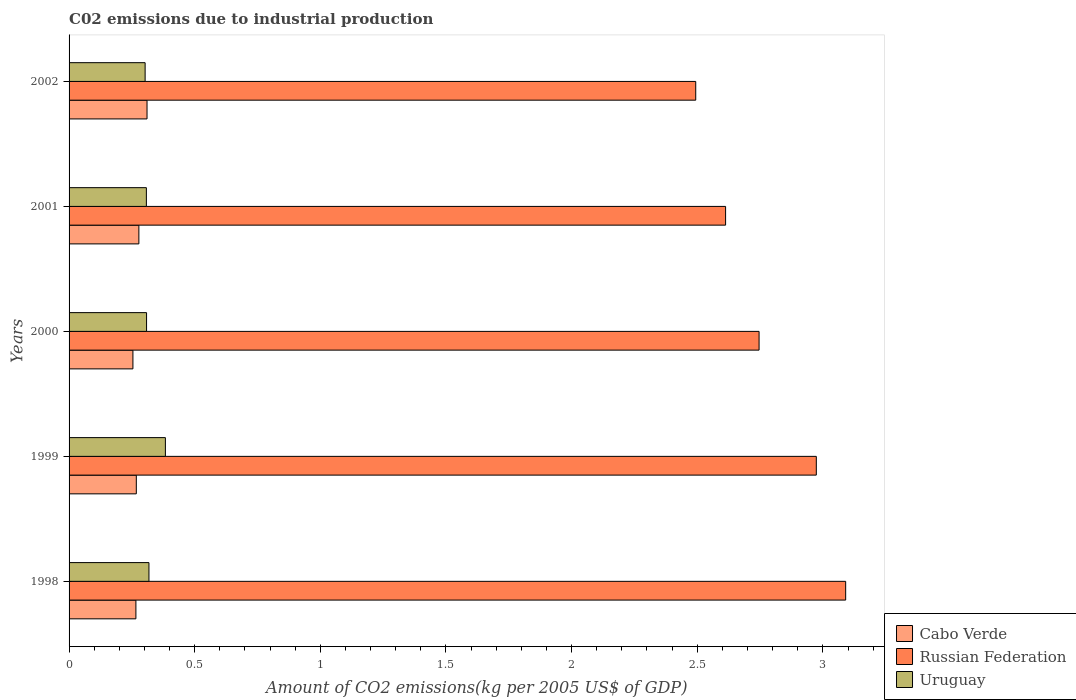How many groups of bars are there?
Your response must be concise. 5. Are the number of bars on each tick of the Y-axis equal?
Make the answer very short. Yes. How many bars are there on the 1st tick from the bottom?
Provide a succinct answer. 3. What is the label of the 2nd group of bars from the top?
Your answer should be very brief. 2001. What is the amount of CO2 emitted due to industrial production in Cabo Verde in 2001?
Ensure brevity in your answer.  0.28. Across all years, what is the maximum amount of CO2 emitted due to industrial production in Cabo Verde?
Offer a very short reply. 0.31. Across all years, what is the minimum amount of CO2 emitted due to industrial production in Uruguay?
Your answer should be very brief. 0.3. In which year was the amount of CO2 emitted due to industrial production in Russian Federation minimum?
Provide a short and direct response. 2002. What is the total amount of CO2 emitted due to industrial production in Uruguay in the graph?
Give a very brief answer. 1.62. What is the difference between the amount of CO2 emitted due to industrial production in Uruguay in 1999 and that in 2002?
Give a very brief answer. 0.08. What is the difference between the amount of CO2 emitted due to industrial production in Uruguay in 2001 and the amount of CO2 emitted due to industrial production in Cabo Verde in 1999?
Your answer should be very brief. 0.04. What is the average amount of CO2 emitted due to industrial production in Russian Federation per year?
Give a very brief answer. 2.78. In the year 1998, what is the difference between the amount of CO2 emitted due to industrial production in Uruguay and amount of CO2 emitted due to industrial production in Cabo Verde?
Keep it short and to the point. 0.05. In how many years, is the amount of CO2 emitted due to industrial production in Cabo Verde greater than 0.8 kg?
Keep it short and to the point. 0. What is the ratio of the amount of CO2 emitted due to industrial production in Cabo Verde in 1998 to that in 2001?
Your response must be concise. 0.96. What is the difference between the highest and the second highest amount of CO2 emitted due to industrial production in Russian Federation?
Make the answer very short. 0.12. What is the difference between the highest and the lowest amount of CO2 emitted due to industrial production in Uruguay?
Ensure brevity in your answer.  0.08. Is the sum of the amount of CO2 emitted due to industrial production in Cabo Verde in 1999 and 2000 greater than the maximum amount of CO2 emitted due to industrial production in Uruguay across all years?
Your response must be concise. Yes. What does the 2nd bar from the top in 2000 represents?
Ensure brevity in your answer.  Russian Federation. What does the 3rd bar from the bottom in 1998 represents?
Give a very brief answer. Uruguay. How many bars are there?
Offer a terse response. 15. Are all the bars in the graph horizontal?
Give a very brief answer. Yes. How many years are there in the graph?
Provide a short and direct response. 5. Are the values on the major ticks of X-axis written in scientific E-notation?
Keep it short and to the point. No. Does the graph contain any zero values?
Offer a very short reply. No. Does the graph contain grids?
Your answer should be very brief. No. Where does the legend appear in the graph?
Your response must be concise. Bottom right. How are the legend labels stacked?
Make the answer very short. Vertical. What is the title of the graph?
Give a very brief answer. C02 emissions due to industrial production. What is the label or title of the X-axis?
Make the answer very short. Amount of CO2 emissions(kg per 2005 US$ of GDP). What is the label or title of the Y-axis?
Offer a terse response. Years. What is the Amount of CO2 emissions(kg per 2005 US$ of GDP) in Cabo Verde in 1998?
Offer a very short reply. 0.27. What is the Amount of CO2 emissions(kg per 2005 US$ of GDP) in Russian Federation in 1998?
Make the answer very short. 3.09. What is the Amount of CO2 emissions(kg per 2005 US$ of GDP) in Uruguay in 1998?
Ensure brevity in your answer.  0.32. What is the Amount of CO2 emissions(kg per 2005 US$ of GDP) of Cabo Verde in 1999?
Your answer should be compact. 0.27. What is the Amount of CO2 emissions(kg per 2005 US$ of GDP) in Russian Federation in 1999?
Your answer should be compact. 2.97. What is the Amount of CO2 emissions(kg per 2005 US$ of GDP) of Uruguay in 1999?
Provide a succinct answer. 0.38. What is the Amount of CO2 emissions(kg per 2005 US$ of GDP) in Cabo Verde in 2000?
Your answer should be compact. 0.25. What is the Amount of CO2 emissions(kg per 2005 US$ of GDP) in Russian Federation in 2000?
Your answer should be compact. 2.75. What is the Amount of CO2 emissions(kg per 2005 US$ of GDP) of Uruguay in 2000?
Your answer should be very brief. 0.31. What is the Amount of CO2 emissions(kg per 2005 US$ of GDP) in Cabo Verde in 2001?
Provide a short and direct response. 0.28. What is the Amount of CO2 emissions(kg per 2005 US$ of GDP) in Russian Federation in 2001?
Offer a terse response. 2.61. What is the Amount of CO2 emissions(kg per 2005 US$ of GDP) in Uruguay in 2001?
Provide a succinct answer. 0.31. What is the Amount of CO2 emissions(kg per 2005 US$ of GDP) of Cabo Verde in 2002?
Provide a short and direct response. 0.31. What is the Amount of CO2 emissions(kg per 2005 US$ of GDP) of Russian Federation in 2002?
Give a very brief answer. 2.49. What is the Amount of CO2 emissions(kg per 2005 US$ of GDP) of Uruguay in 2002?
Ensure brevity in your answer.  0.3. Across all years, what is the maximum Amount of CO2 emissions(kg per 2005 US$ of GDP) of Cabo Verde?
Ensure brevity in your answer.  0.31. Across all years, what is the maximum Amount of CO2 emissions(kg per 2005 US$ of GDP) of Russian Federation?
Your answer should be compact. 3.09. Across all years, what is the maximum Amount of CO2 emissions(kg per 2005 US$ of GDP) in Uruguay?
Ensure brevity in your answer.  0.38. Across all years, what is the minimum Amount of CO2 emissions(kg per 2005 US$ of GDP) of Cabo Verde?
Offer a terse response. 0.25. Across all years, what is the minimum Amount of CO2 emissions(kg per 2005 US$ of GDP) of Russian Federation?
Your response must be concise. 2.49. Across all years, what is the minimum Amount of CO2 emissions(kg per 2005 US$ of GDP) in Uruguay?
Make the answer very short. 0.3. What is the total Amount of CO2 emissions(kg per 2005 US$ of GDP) of Cabo Verde in the graph?
Ensure brevity in your answer.  1.38. What is the total Amount of CO2 emissions(kg per 2005 US$ of GDP) in Russian Federation in the graph?
Ensure brevity in your answer.  13.92. What is the total Amount of CO2 emissions(kg per 2005 US$ of GDP) of Uruguay in the graph?
Ensure brevity in your answer.  1.62. What is the difference between the Amount of CO2 emissions(kg per 2005 US$ of GDP) of Cabo Verde in 1998 and that in 1999?
Your response must be concise. -0. What is the difference between the Amount of CO2 emissions(kg per 2005 US$ of GDP) in Russian Federation in 1998 and that in 1999?
Make the answer very short. 0.12. What is the difference between the Amount of CO2 emissions(kg per 2005 US$ of GDP) of Uruguay in 1998 and that in 1999?
Provide a succinct answer. -0.07. What is the difference between the Amount of CO2 emissions(kg per 2005 US$ of GDP) of Cabo Verde in 1998 and that in 2000?
Your response must be concise. 0.01. What is the difference between the Amount of CO2 emissions(kg per 2005 US$ of GDP) of Russian Federation in 1998 and that in 2000?
Your answer should be very brief. 0.34. What is the difference between the Amount of CO2 emissions(kg per 2005 US$ of GDP) of Uruguay in 1998 and that in 2000?
Keep it short and to the point. 0.01. What is the difference between the Amount of CO2 emissions(kg per 2005 US$ of GDP) in Cabo Verde in 1998 and that in 2001?
Ensure brevity in your answer.  -0.01. What is the difference between the Amount of CO2 emissions(kg per 2005 US$ of GDP) in Russian Federation in 1998 and that in 2001?
Offer a very short reply. 0.48. What is the difference between the Amount of CO2 emissions(kg per 2005 US$ of GDP) of Uruguay in 1998 and that in 2001?
Keep it short and to the point. 0.01. What is the difference between the Amount of CO2 emissions(kg per 2005 US$ of GDP) in Cabo Verde in 1998 and that in 2002?
Give a very brief answer. -0.04. What is the difference between the Amount of CO2 emissions(kg per 2005 US$ of GDP) in Russian Federation in 1998 and that in 2002?
Offer a terse response. 0.6. What is the difference between the Amount of CO2 emissions(kg per 2005 US$ of GDP) of Uruguay in 1998 and that in 2002?
Provide a short and direct response. 0.02. What is the difference between the Amount of CO2 emissions(kg per 2005 US$ of GDP) in Cabo Verde in 1999 and that in 2000?
Ensure brevity in your answer.  0.01. What is the difference between the Amount of CO2 emissions(kg per 2005 US$ of GDP) in Russian Federation in 1999 and that in 2000?
Keep it short and to the point. 0.23. What is the difference between the Amount of CO2 emissions(kg per 2005 US$ of GDP) in Uruguay in 1999 and that in 2000?
Offer a very short reply. 0.07. What is the difference between the Amount of CO2 emissions(kg per 2005 US$ of GDP) of Cabo Verde in 1999 and that in 2001?
Make the answer very short. -0.01. What is the difference between the Amount of CO2 emissions(kg per 2005 US$ of GDP) of Russian Federation in 1999 and that in 2001?
Your answer should be compact. 0.36. What is the difference between the Amount of CO2 emissions(kg per 2005 US$ of GDP) of Uruguay in 1999 and that in 2001?
Make the answer very short. 0.08. What is the difference between the Amount of CO2 emissions(kg per 2005 US$ of GDP) of Cabo Verde in 1999 and that in 2002?
Keep it short and to the point. -0.04. What is the difference between the Amount of CO2 emissions(kg per 2005 US$ of GDP) in Russian Federation in 1999 and that in 2002?
Keep it short and to the point. 0.48. What is the difference between the Amount of CO2 emissions(kg per 2005 US$ of GDP) in Uruguay in 1999 and that in 2002?
Your answer should be compact. 0.08. What is the difference between the Amount of CO2 emissions(kg per 2005 US$ of GDP) of Cabo Verde in 2000 and that in 2001?
Give a very brief answer. -0.02. What is the difference between the Amount of CO2 emissions(kg per 2005 US$ of GDP) of Russian Federation in 2000 and that in 2001?
Offer a terse response. 0.13. What is the difference between the Amount of CO2 emissions(kg per 2005 US$ of GDP) of Uruguay in 2000 and that in 2001?
Offer a very short reply. 0. What is the difference between the Amount of CO2 emissions(kg per 2005 US$ of GDP) of Cabo Verde in 2000 and that in 2002?
Provide a short and direct response. -0.06. What is the difference between the Amount of CO2 emissions(kg per 2005 US$ of GDP) of Russian Federation in 2000 and that in 2002?
Give a very brief answer. 0.25. What is the difference between the Amount of CO2 emissions(kg per 2005 US$ of GDP) in Uruguay in 2000 and that in 2002?
Keep it short and to the point. 0.01. What is the difference between the Amount of CO2 emissions(kg per 2005 US$ of GDP) of Cabo Verde in 2001 and that in 2002?
Give a very brief answer. -0.03. What is the difference between the Amount of CO2 emissions(kg per 2005 US$ of GDP) of Russian Federation in 2001 and that in 2002?
Provide a short and direct response. 0.12. What is the difference between the Amount of CO2 emissions(kg per 2005 US$ of GDP) in Uruguay in 2001 and that in 2002?
Provide a short and direct response. 0.01. What is the difference between the Amount of CO2 emissions(kg per 2005 US$ of GDP) in Cabo Verde in 1998 and the Amount of CO2 emissions(kg per 2005 US$ of GDP) in Russian Federation in 1999?
Make the answer very short. -2.71. What is the difference between the Amount of CO2 emissions(kg per 2005 US$ of GDP) of Cabo Verde in 1998 and the Amount of CO2 emissions(kg per 2005 US$ of GDP) of Uruguay in 1999?
Offer a very short reply. -0.12. What is the difference between the Amount of CO2 emissions(kg per 2005 US$ of GDP) of Russian Federation in 1998 and the Amount of CO2 emissions(kg per 2005 US$ of GDP) of Uruguay in 1999?
Your answer should be very brief. 2.71. What is the difference between the Amount of CO2 emissions(kg per 2005 US$ of GDP) of Cabo Verde in 1998 and the Amount of CO2 emissions(kg per 2005 US$ of GDP) of Russian Federation in 2000?
Your answer should be very brief. -2.48. What is the difference between the Amount of CO2 emissions(kg per 2005 US$ of GDP) of Cabo Verde in 1998 and the Amount of CO2 emissions(kg per 2005 US$ of GDP) of Uruguay in 2000?
Your answer should be compact. -0.04. What is the difference between the Amount of CO2 emissions(kg per 2005 US$ of GDP) of Russian Federation in 1998 and the Amount of CO2 emissions(kg per 2005 US$ of GDP) of Uruguay in 2000?
Ensure brevity in your answer.  2.78. What is the difference between the Amount of CO2 emissions(kg per 2005 US$ of GDP) of Cabo Verde in 1998 and the Amount of CO2 emissions(kg per 2005 US$ of GDP) of Russian Federation in 2001?
Offer a very short reply. -2.35. What is the difference between the Amount of CO2 emissions(kg per 2005 US$ of GDP) in Cabo Verde in 1998 and the Amount of CO2 emissions(kg per 2005 US$ of GDP) in Uruguay in 2001?
Offer a terse response. -0.04. What is the difference between the Amount of CO2 emissions(kg per 2005 US$ of GDP) of Russian Federation in 1998 and the Amount of CO2 emissions(kg per 2005 US$ of GDP) of Uruguay in 2001?
Your response must be concise. 2.78. What is the difference between the Amount of CO2 emissions(kg per 2005 US$ of GDP) of Cabo Verde in 1998 and the Amount of CO2 emissions(kg per 2005 US$ of GDP) of Russian Federation in 2002?
Your answer should be compact. -2.23. What is the difference between the Amount of CO2 emissions(kg per 2005 US$ of GDP) of Cabo Verde in 1998 and the Amount of CO2 emissions(kg per 2005 US$ of GDP) of Uruguay in 2002?
Offer a very short reply. -0.04. What is the difference between the Amount of CO2 emissions(kg per 2005 US$ of GDP) of Russian Federation in 1998 and the Amount of CO2 emissions(kg per 2005 US$ of GDP) of Uruguay in 2002?
Keep it short and to the point. 2.79. What is the difference between the Amount of CO2 emissions(kg per 2005 US$ of GDP) of Cabo Verde in 1999 and the Amount of CO2 emissions(kg per 2005 US$ of GDP) of Russian Federation in 2000?
Offer a terse response. -2.48. What is the difference between the Amount of CO2 emissions(kg per 2005 US$ of GDP) of Cabo Verde in 1999 and the Amount of CO2 emissions(kg per 2005 US$ of GDP) of Uruguay in 2000?
Your answer should be compact. -0.04. What is the difference between the Amount of CO2 emissions(kg per 2005 US$ of GDP) of Russian Federation in 1999 and the Amount of CO2 emissions(kg per 2005 US$ of GDP) of Uruguay in 2000?
Keep it short and to the point. 2.67. What is the difference between the Amount of CO2 emissions(kg per 2005 US$ of GDP) in Cabo Verde in 1999 and the Amount of CO2 emissions(kg per 2005 US$ of GDP) in Russian Federation in 2001?
Provide a short and direct response. -2.35. What is the difference between the Amount of CO2 emissions(kg per 2005 US$ of GDP) in Cabo Verde in 1999 and the Amount of CO2 emissions(kg per 2005 US$ of GDP) in Uruguay in 2001?
Your answer should be compact. -0.04. What is the difference between the Amount of CO2 emissions(kg per 2005 US$ of GDP) of Russian Federation in 1999 and the Amount of CO2 emissions(kg per 2005 US$ of GDP) of Uruguay in 2001?
Provide a succinct answer. 2.67. What is the difference between the Amount of CO2 emissions(kg per 2005 US$ of GDP) in Cabo Verde in 1999 and the Amount of CO2 emissions(kg per 2005 US$ of GDP) in Russian Federation in 2002?
Ensure brevity in your answer.  -2.23. What is the difference between the Amount of CO2 emissions(kg per 2005 US$ of GDP) of Cabo Verde in 1999 and the Amount of CO2 emissions(kg per 2005 US$ of GDP) of Uruguay in 2002?
Your answer should be very brief. -0.04. What is the difference between the Amount of CO2 emissions(kg per 2005 US$ of GDP) in Russian Federation in 1999 and the Amount of CO2 emissions(kg per 2005 US$ of GDP) in Uruguay in 2002?
Ensure brevity in your answer.  2.67. What is the difference between the Amount of CO2 emissions(kg per 2005 US$ of GDP) in Cabo Verde in 2000 and the Amount of CO2 emissions(kg per 2005 US$ of GDP) in Russian Federation in 2001?
Make the answer very short. -2.36. What is the difference between the Amount of CO2 emissions(kg per 2005 US$ of GDP) in Cabo Verde in 2000 and the Amount of CO2 emissions(kg per 2005 US$ of GDP) in Uruguay in 2001?
Your response must be concise. -0.05. What is the difference between the Amount of CO2 emissions(kg per 2005 US$ of GDP) of Russian Federation in 2000 and the Amount of CO2 emissions(kg per 2005 US$ of GDP) of Uruguay in 2001?
Your answer should be very brief. 2.44. What is the difference between the Amount of CO2 emissions(kg per 2005 US$ of GDP) in Cabo Verde in 2000 and the Amount of CO2 emissions(kg per 2005 US$ of GDP) in Russian Federation in 2002?
Provide a succinct answer. -2.24. What is the difference between the Amount of CO2 emissions(kg per 2005 US$ of GDP) in Cabo Verde in 2000 and the Amount of CO2 emissions(kg per 2005 US$ of GDP) in Uruguay in 2002?
Your answer should be very brief. -0.05. What is the difference between the Amount of CO2 emissions(kg per 2005 US$ of GDP) in Russian Federation in 2000 and the Amount of CO2 emissions(kg per 2005 US$ of GDP) in Uruguay in 2002?
Give a very brief answer. 2.44. What is the difference between the Amount of CO2 emissions(kg per 2005 US$ of GDP) of Cabo Verde in 2001 and the Amount of CO2 emissions(kg per 2005 US$ of GDP) of Russian Federation in 2002?
Give a very brief answer. -2.22. What is the difference between the Amount of CO2 emissions(kg per 2005 US$ of GDP) of Cabo Verde in 2001 and the Amount of CO2 emissions(kg per 2005 US$ of GDP) of Uruguay in 2002?
Your response must be concise. -0.02. What is the difference between the Amount of CO2 emissions(kg per 2005 US$ of GDP) in Russian Federation in 2001 and the Amount of CO2 emissions(kg per 2005 US$ of GDP) in Uruguay in 2002?
Ensure brevity in your answer.  2.31. What is the average Amount of CO2 emissions(kg per 2005 US$ of GDP) in Cabo Verde per year?
Provide a short and direct response. 0.28. What is the average Amount of CO2 emissions(kg per 2005 US$ of GDP) of Russian Federation per year?
Give a very brief answer. 2.78. What is the average Amount of CO2 emissions(kg per 2005 US$ of GDP) in Uruguay per year?
Your answer should be very brief. 0.32. In the year 1998, what is the difference between the Amount of CO2 emissions(kg per 2005 US$ of GDP) in Cabo Verde and Amount of CO2 emissions(kg per 2005 US$ of GDP) in Russian Federation?
Your response must be concise. -2.82. In the year 1998, what is the difference between the Amount of CO2 emissions(kg per 2005 US$ of GDP) of Cabo Verde and Amount of CO2 emissions(kg per 2005 US$ of GDP) of Uruguay?
Your response must be concise. -0.05. In the year 1998, what is the difference between the Amount of CO2 emissions(kg per 2005 US$ of GDP) of Russian Federation and Amount of CO2 emissions(kg per 2005 US$ of GDP) of Uruguay?
Your response must be concise. 2.77. In the year 1999, what is the difference between the Amount of CO2 emissions(kg per 2005 US$ of GDP) in Cabo Verde and Amount of CO2 emissions(kg per 2005 US$ of GDP) in Russian Federation?
Ensure brevity in your answer.  -2.71. In the year 1999, what is the difference between the Amount of CO2 emissions(kg per 2005 US$ of GDP) of Cabo Verde and Amount of CO2 emissions(kg per 2005 US$ of GDP) of Uruguay?
Provide a short and direct response. -0.12. In the year 1999, what is the difference between the Amount of CO2 emissions(kg per 2005 US$ of GDP) in Russian Federation and Amount of CO2 emissions(kg per 2005 US$ of GDP) in Uruguay?
Offer a terse response. 2.59. In the year 2000, what is the difference between the Amount of CO2 emissions(kg per 2005 US$ of GDP) of Cabo Verde and Amount of CO2 emissions(kg per 2005 US$ of GDP) of Russian Federation?
Provide a succinct answer. -2.49. In the year 2000, what is the difference between the Amount of CO2 emissions(kg per 2005 US$ of GDP) of Cabo Verde and Amount of CO2 emissions(kg per 2005 US$ of GDP) of Uruguay?
Make the answer very short. -0.05. In the year 2000, what is the difference between the Amount of CO2 emissions(kg per 2005 US$ of GDP) in Russian Federation and Amount of CO2 emissions(kg per 2005 US$ of GDP) in Uruguay?
Keep it short and to the point. 2.44. In the year 2001, what is the difference between the Amount of CO2 emissions(kg per 2005 US$ of GDP) in Cabo Verde and Amount of CO2 emissions(kg per 2005 US$ of GDP) in Russian Federation?
Give a very brief answer. -2.34. In the year 2001, what is the difference between the Amount of CO2 emissions(kg per 2005 US$ of GDP) of Cabo Verde and Amount of CO2 emissions(kg per 2005 US$ of GDP) of Uruguay?
Ensure brevity in your answer.  -0.03. In the year 2001, what is the difference between the Amount of CO2 emissions(kg per 2005 US$ of GDP) in Russian Federation and Amount of CO2 emissions(kg per 2005 US$ of GDP) in Uruguay?
Ensure brevity in your answer.  2.31. In the year 2002, what is the difference between the Amount of CO2 emissions(kg per 2005 US$ of GDP) in Cabo Verde and Amount of CO2 emissions(kg per 2005 US$ of GDP) in Russian Federation?
Give a very brief answer. -2.18. In the year 2002, what is the difference between the Amount of CO2 emissions(kg per 2005 US$ of GDP) in Cabo Verde and Amount of CO2 emissions(kg per 2005 US$ of GDP) in Uruguay?
Keep it short and to the point. 0.01. In the year 2002, what is the difference between the Amount of CO2 emissions(kg per 2005 US$ of GDP) in Russian Federation and Amount of CO2 emissions(kg per 2005 US$ of GDP) in Uruguay?
Provide a short and direct response. 2.19. What is the ratio of the Amount of CO2 emissions(kg per 2005 US$ of GDP) in Russian Federation in 1998 to that in 1999?
Offer a very short reply. 1.04. What is the ratio of the Amount of CO2 emissions(kg per 2005 US$ of GDP) in Uruguay in 1998 to that in 1999?
Make the answer very short. 0.83. What is the ratio of the Amount of CO2 emissions(kg per 2005 US$ of GDP) of Cabo Verde in 1998 to that in 2000?
Ensure brevity in your answer.  1.05. What is the ratio of the Amount of CO2 emissions(kg per 2005 US$ of GDP) of Russian Federation in 1998 to that in 2000?
Provide a short and direct response. 1.13. What is the ratio of the Amount of CO2 emissions(kg per 2005 US$ of GDP) in Uruguay in 1998 to that in 2000?
Offer a very short reply. 1.03. What is the ratio of the Amount of CO2 emissions(kg per 2005 US$ of GDP) of Cabo Verde in 1998 to that in 2001?
Offer a terse response. 0.96. What is the ratio of the Amount of CO2 emissions(kg per 2005 US$ of GDP) in Russian Federation in 1998 to that in 2001?
Keep it short and to the point. 1.18. What is the ratio of the Amount of CO2 emissions(kg per 2005 US$ of GDP) of Cabo Verde in 1998 to that in 2002?
Your answer should be compact. 0.86. What is the ratio of the Amount of CO2 emissions(kg per 2005 US$ of GDP) of Russian Federation in 1998 to that in 2002?
Provide a short and direct response. 1.24. What is the ratio of the Amount of CO2 emissions(kg per 2005 US$ of GDP) in Uruguay in 1998 to that in 2002?
Offer a very short reply. 1.05. What is the ratio of the Amount of CO2 emissions(kg per 2005 US$ of GDP) of Cabo Verde in 1999 to that in 2000?
Ensure brevity in your answer.  1.05. What is the ratio of the Amount of CO2 emissions(kg per 2005 US$ of GDP) of Russian Federation in 1999 to that in 2000?
Provide a short and direct response. 1.08. What is the ratio of the Amount of CO2 emissions(kg per 2005 US$ of GDP) of Uruguay in 1999 to that in 2000?
Provide a short and direct response. 1.24. What is the ratio of the Amount of CO2 emissions(kg per 2005 US$ of GDP) of Cabo Verde in 1999 to that in 2001?
Provide a succinct answer. 0.96. What is the ratio of the Amount of CO2 emissions(kg per 2005 US$ of GDP) in Russian Federation in 1999 to that in 2001?
Provide a short and direct response. 1.14. What is the ratio of the Amount of CO2 emissions(kg per 2005 US$ of GDP) of Uruguay in 1999 to that in 2001?
Your response must be concise. 1.25. What is the ratio of the Amount of CO2 emissions(kg per 2005 US$ of GDP) of Cabo Verde in 1999 to that in 2002?
Your answer should be very brief. 0.86. What is the ratio of the Amount of CO2 emissions(kg per 2005 US$ of GDP) of Russian Federation in 1999 to that in 2002?
Your response must be concise. 1.19. What is the ratio of the Amount of CO2 emissions(kg per 2005 US$ of GDP) in Uruguay in 1999 to that in 2002?
Your response must be concise. 1.27. What is the ratio of the Amount of CO2 emissions(kg per 2005 US$ of GDP) in Cabo Verde in 2000 to that in 2001?
Offer a very short reply. 0.91. What is the ratio of the Amount of CO2 emissions(kg per 2005 US$ of GDP) in Russian Federation in 2000 to that in 2001?
Offer a very short reply. 1.05. What is the ratio of the Amount of CO2 emissions(kg per 2005 US$ of GDP) in Cabo Verde in 2000 to that in 2002?
Offer a terse response. 0.82. What is the ratio of the Amount of CO2 emissions(kg per 2005 US$ of GDP) in Russian Federation in 2000 to that in 2002?
Your response must be concise. 1.1. What is the ratio of the Amount of CO2 emissions(kg per 2005 US$ of GDP) of Uruguay in 2000 to that in 2002?
Keep it short and to the point. 1.02. What is the ratio of the Amount of CO2 emissions(kg per 2005 US$ of GDP) of Cabo Verde in 2001 to that in 2002?
Your answer should be very brief. 0.9. What is the ratio of the Amount of CO2 emissions(kg per 2005 US$ of GDP) of Russian Federation in 2001 to that in 2002?
Offer a very short reply. 1.05. What is the ratio of the Amount of CO2 emissions(kg per 2005 US$ of GDP) in Uruguay in 2001 to that in 2002?
Make the answer very short. 1.02. What is the difference between the highest and the second highest Amount of CO2 emissions(kg per 2005 US$ of GDP) in Cabo Verde?
Provide a short and direct response. 0.03. What is the difference between the highest and the second highest Amount of CO2 emissions(kg per 2005 US$ of GDP) in Russian Federation?
Your response must be concise. 0.12. What is the difference between the highest and the second highest Amount of CO2 emissions(kg per 2005 US$ of GDP) of Uruguay?
Your response must be concise. 0.07. What is the difference between the highest and the lowest Amount of CO2 emissions(kg per 2005 US$ of GDP) in Cabo Verde?
Offer a very short reply. 0.06. What is the difference between the highest and the lowest Amount of CO2 emissions(kg per 2005 US$ of GDP) in Russian Federation?
Ensure brevity in your answer.  0.6. What is the difference between the highest and the lowest Amount of CO2 emissions(kg per 2005 US$ of GDP) of Uruguay?
Make the answer very short. 0.08. 